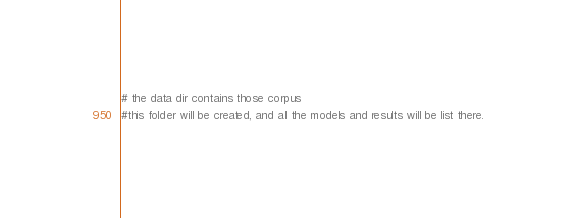Convert code to text. <code><loc_0><loc_0><loc_500><loc_500><_Bash_># the data dir contains those corpus
#this folder will be created, and all the models and results will be list there.</code> 